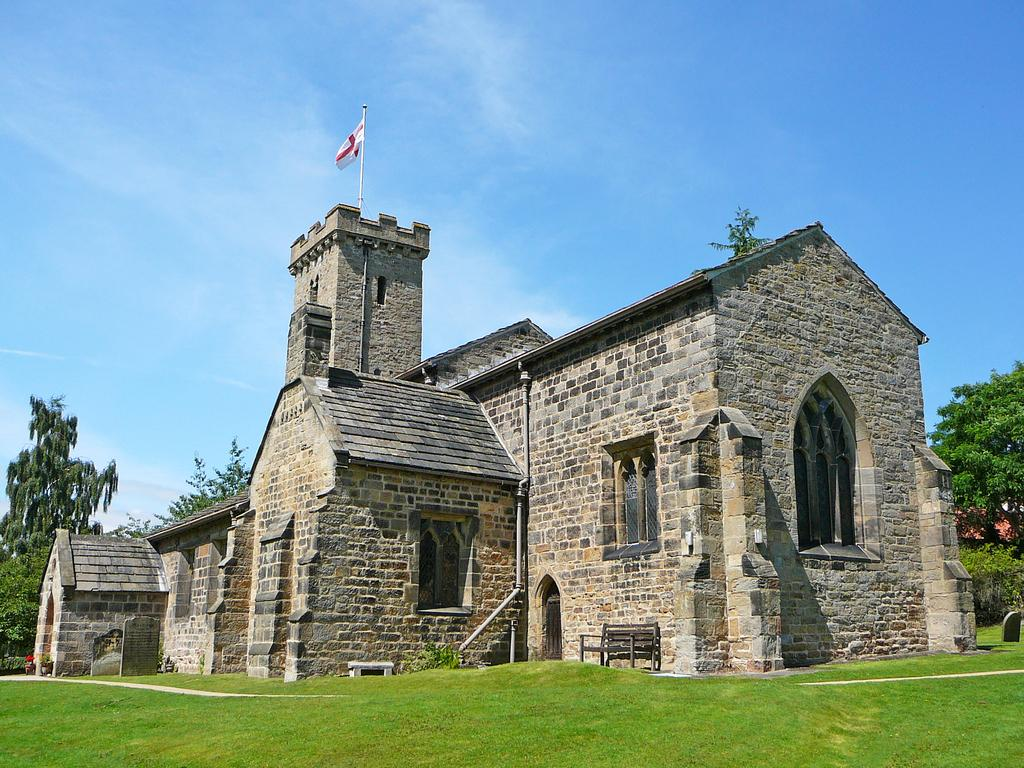What type of ground surface is visible at the bottom of the image? There is grass on the ground at the bottom of the image. What can be seen in the background of the image? There is a building and trees in the background of the image. What feature of the building is mentioned in the facts? The building has windows. What is visible in the sky in the image? There are clouds in the sky. Where is the rabbit playing in the field in the image? There is no rabbit or field present in the image. What type of fire can be seen burning in the image? There is no fire present in the image. 